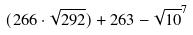Convert formula to latex. <formula><loc_0><loc_0><loc_500><loc_500>( 2 6 6 \cdot \sqrt { 2 9 2 } ) + 2 6 3 - \sqrt { 1 0 } ^ { 7 }</formula> 